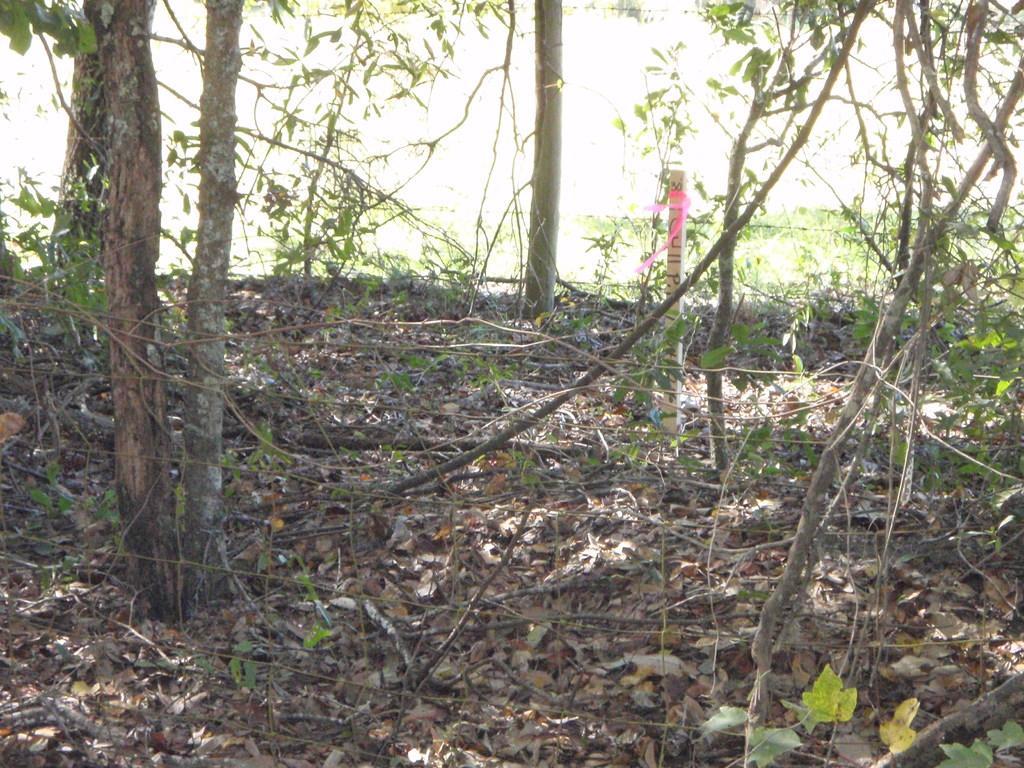Describe this image in one or two sentences. In this image we can see the trunk of trees. Here we can see the branches of trees. Here we can see the leaves on the ground. 